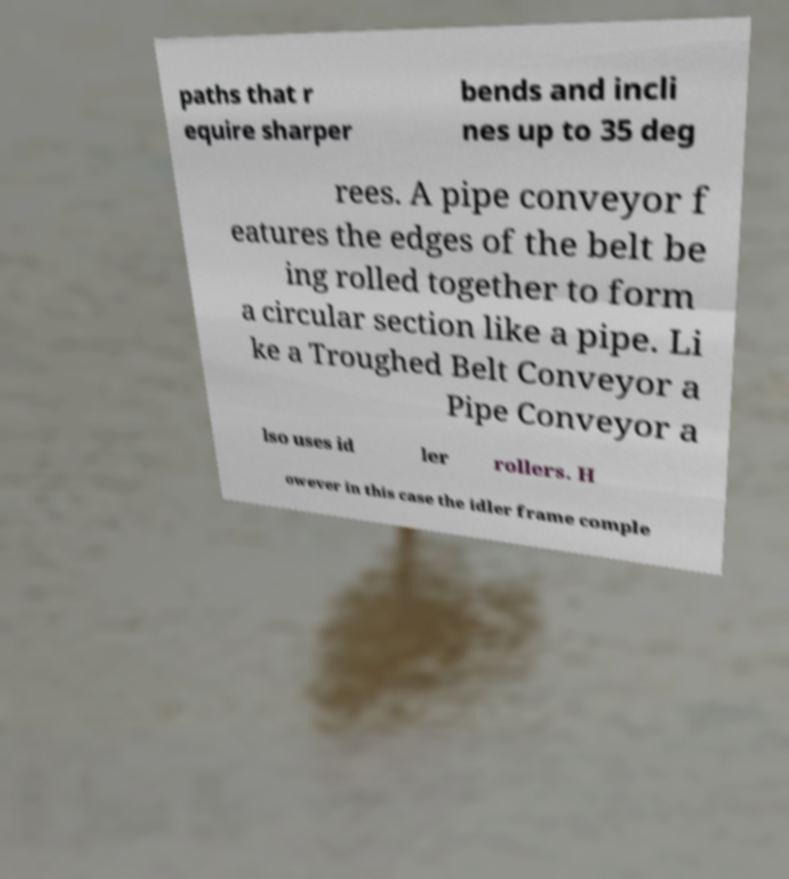Can you accurately transcribe the text from the provided image for me? paths that r equire sharper bends and incli nes up to 35 deg rees. A pipe conveyor f eatures the edges of the belt be ing rolled together to form a circular section like a pipe. Li ke a Troughed Belt Conveyor a Pipe Conveyor a lso uses id ler rollers. H owever in this case the idler frame comple 